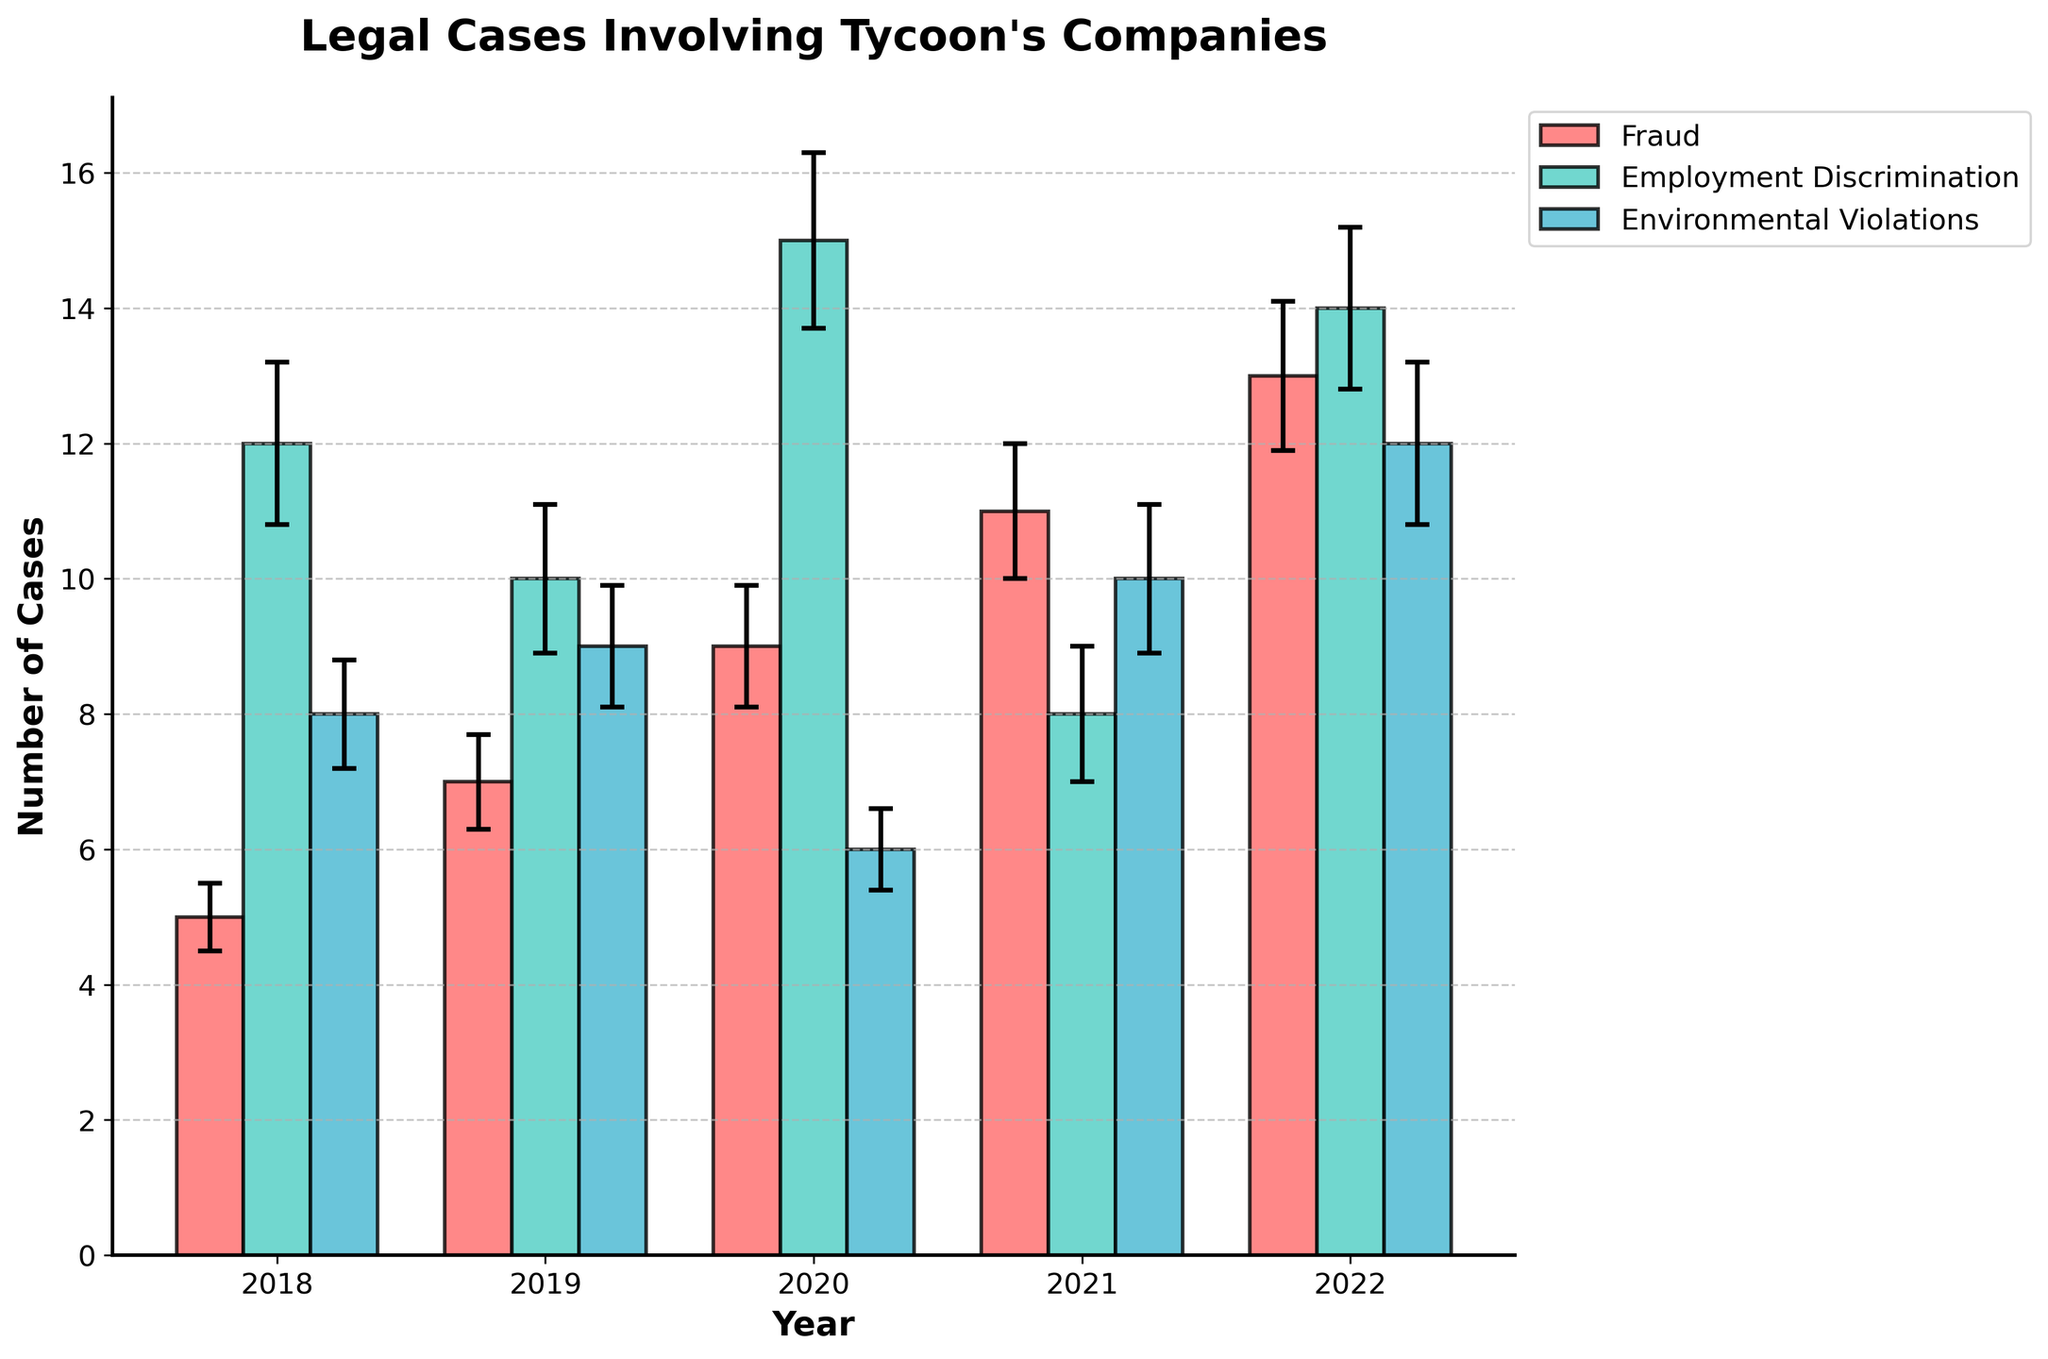What is the title of the chart? The title of the chart is displayed at the top and typically provides an overview of the data being visualized. In this case, it is "Legal Cases Involving Tycoon's Companies."
Answer: Legal Cases Involving Tycoon's Companies What is the x-axis label? The x-axis label is displayed horizontally and indicates the category of data represented along the x-axis, which in this case are the years.
Answer: Year How many types of lawsuits are shown in the chart? The legend in the chart shows three different lawsuit types, identifiable by their distinct colors.
Answer: Three Which year had the highest number of employment discrimination cases? By observing the height of the bars for Employment Discrimination cases, the year 2020 has the tallest bar for this category.
Answer: 2020 What are the error bars used for in this chart? The error bars represent the standard error for each data point, providing a visual indication of the variability or uncertainty around the measured number of cases.
Answer: Standard error How does the number of fraud cases change from 2018 to 2022? Examining the bars for Fraud cases from 2018 to 2022, they increase in height over time. Starting at 5 in 2018 and reaching 13 in 2022.
Answer: Increase Compare the number of environmental violation cases in 2019 and 2021. Looking at the bars for Environmental Violations, the number of cases in 2019 is 9, whereas in 2021 it is 10.
Answer: 10 is greater than 9 What was the total number of cases for all types of lawsuits in 2020? To find the total, sum the number of cases for Fraud (9), Employment Discrimination (15), and Environmental Violations (6): 9 + 15 + 6 = 30.
Answer: 30 In which year and for which type of lawsuit does the chart show the smallest standard error? By comparing the error bars, the smallest standard error appears in the 2020 Environmental Violations data, with a standard error of 0.6.
Answer: 2020 Environmental Violations What is the average number of environmental violation cases from 2018 to 2022? Calculate the average by summing up the number of cases for Environmental Violations each year (8 + 9 + 6 + 10 + 12 = 45) and dividing by 5 (the number of years). So, 45/5 = 9.
Answer: 9 